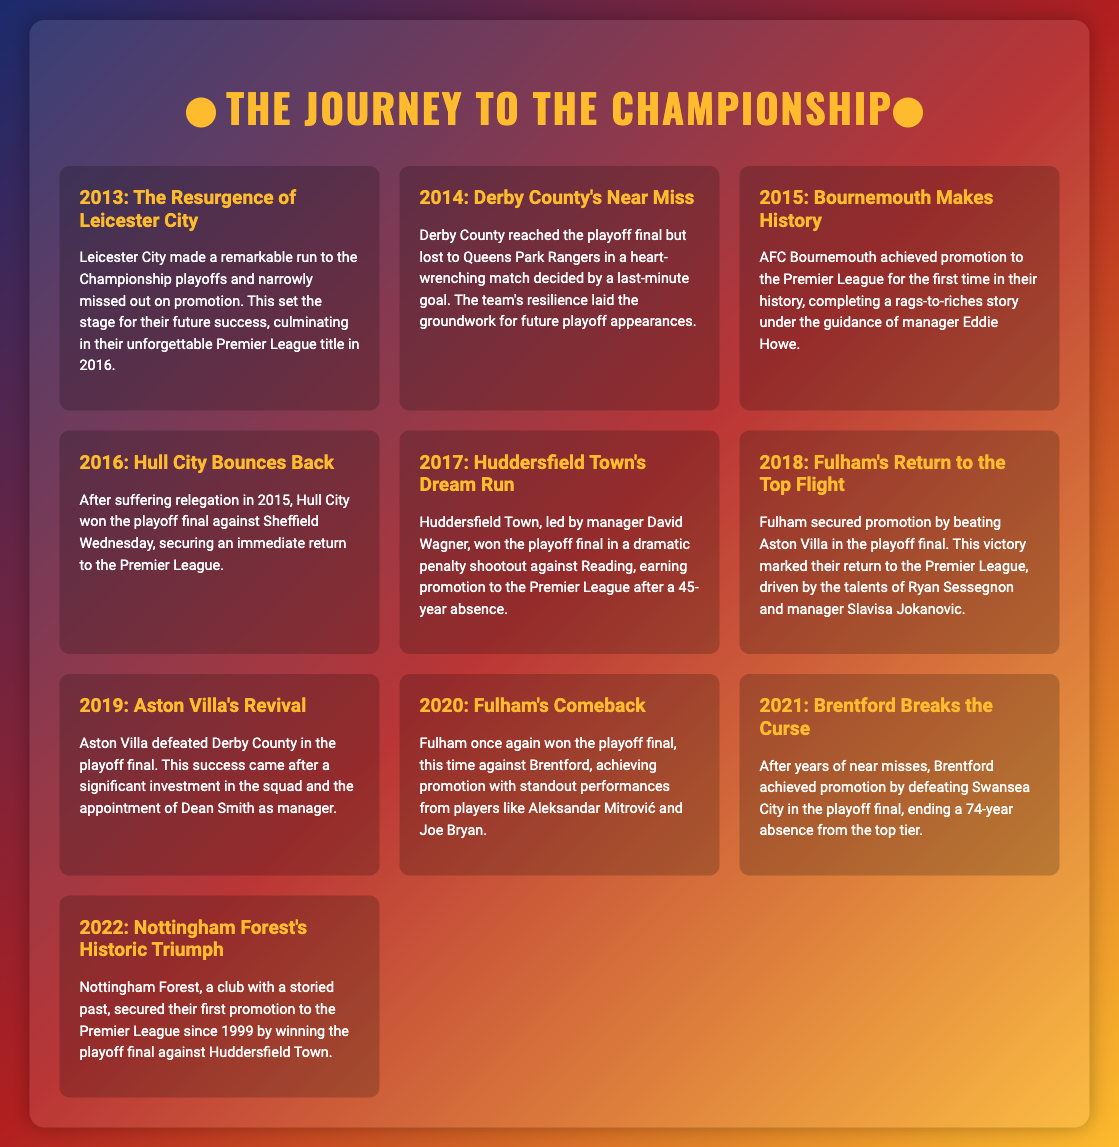What year did Leicester City make a playoff run? The document states that Leicester City made a remarkable run to the Championship playoffs in 2013.
Answer: 2013 Which team lost in the playoff final in 2014? According to the document, Derby County reached the playoff final but lost to Queens Park Rangers.
Answer: Queens Park Rangers Who managed Bournemouth during their promotion in 2015? The text indicates that AFC Bournemouth achieved promotion under the guidance of manager Eddie Howe in 2015.
Answer: Eddie Howe How many teams won the playoff final consecutively in 2020 and 2021? The document mentions Fulham in 2020 and Brentford in 2021, showing two distinct teams winning consecutively in two years.
Answer: 2 What significant event occurred for Huddersfield Town in 2017? The document notes that Huddersfield Town won the playoff final in a dramatic penalty shootout, marking an important milestone.
Answer: Won the playoff final Which club achieved their first Premier League promotion since 1999? The document states that Nottingham Forest secured their first promotion to the Premier League since 1999 in 2022.
Answer: Nottingham Forest What city is associated with the team that won the 2021 playoff final? The document indicates that Brentford achieved promotion by defeating Swansea City in the playoff final in 2021, relating the two cities.
Answer: Brentford What marked Fulham's return to the Premier League in 2018? According to the document, Fulham secured promotion by beating Aston Villa in the playoff final in 2018, symbolizing their return.
Answer: Beat Aston Villa 